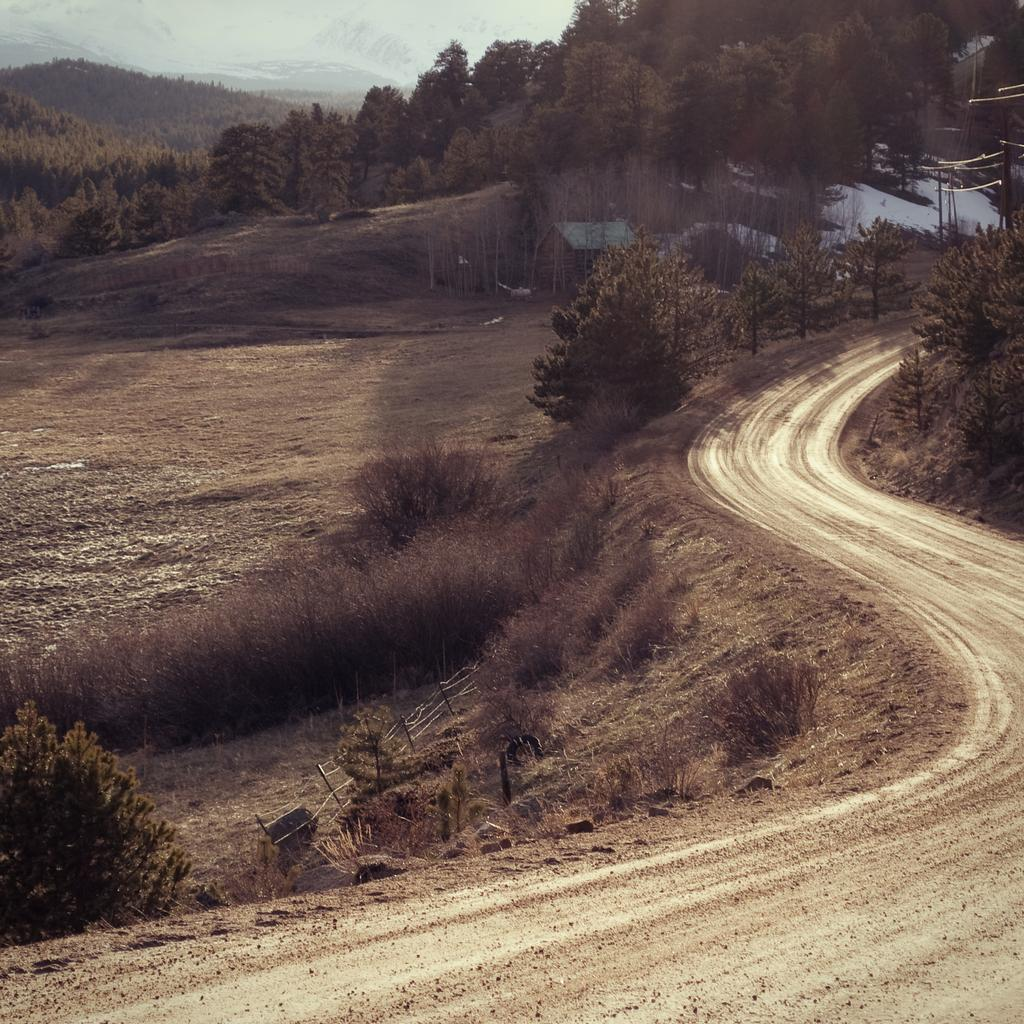What can be seen on the right side at the bottom of the image? There is a path on the right side at the bottom of the image. What type of vegetation is present on the ground in the image? There is grass on the ground in the image. What other natural elements can be seen in the image? There are trees in the image. What is visible in the background of the image? There are hills in the background of the image. What type of jelly can be seen on the trees in the image? There is no jelly present on the trees in the image; it is a natural scene with grass, trees, and hills. What type of picture is being taken of the scene in the image? The image itself is a picture of the scene, so there is no additional picture being taken within the image. 